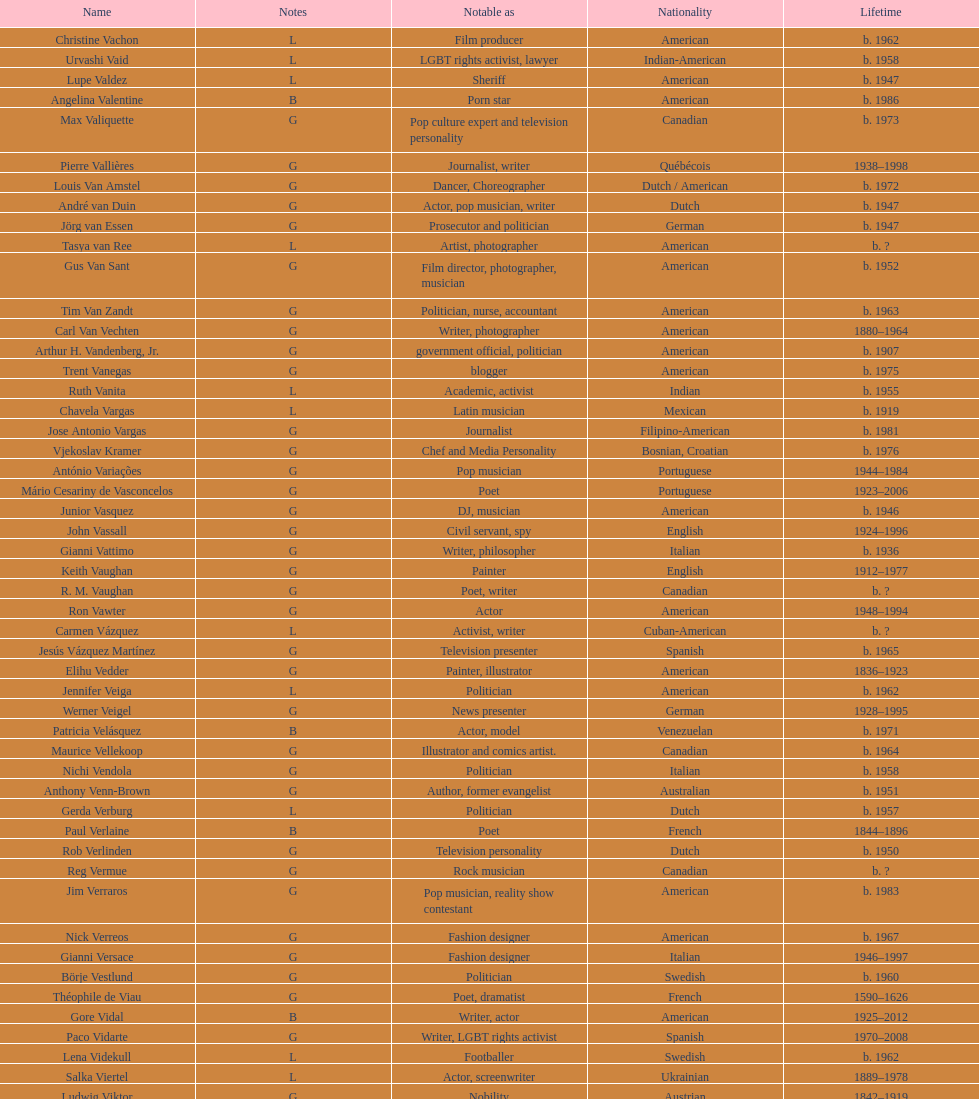Which nationality had the larger amount of names listed? American. 